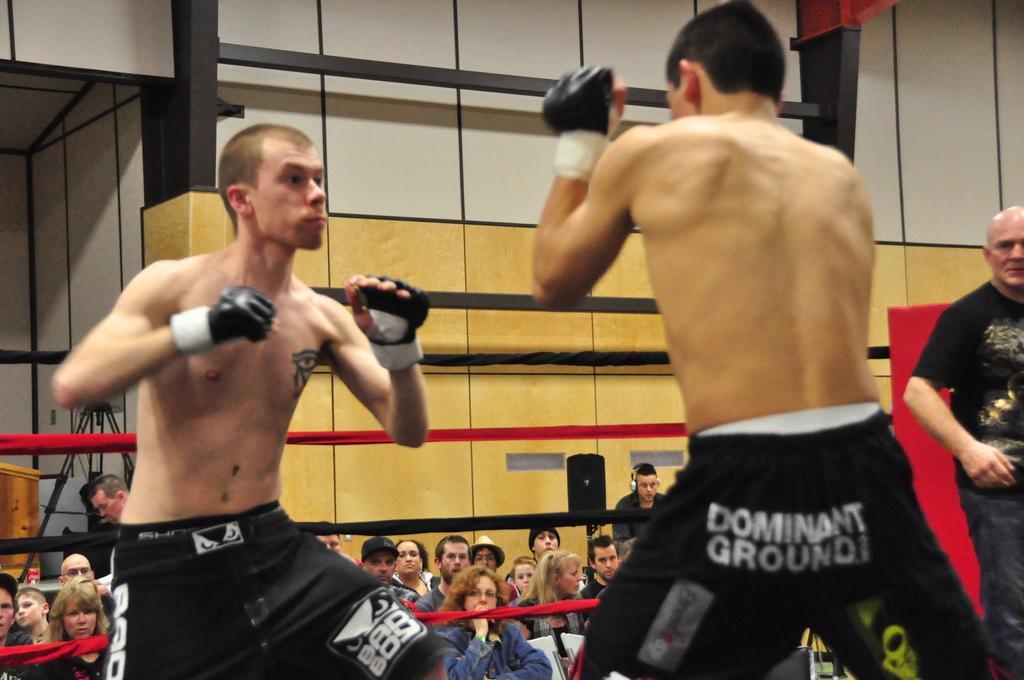Describe this image in one or two sentences. In this picture there are two persons who are wearing a black shirt and gloves. Both of them are doing boxing. On the right we can see umpire who is wearing t-shirt and trouser. He is standing near to the ropes. On the bottom we can see audience who are watching the game. Here we can see a man who is wearing headphones and black hoodie, standing near to the wall. On the left background we can see a speech desk and camera stand. 